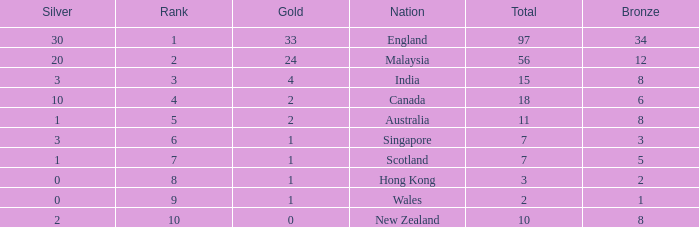What is the highest rank a team with 1 silver and less than 5 bronze medals has? None. 